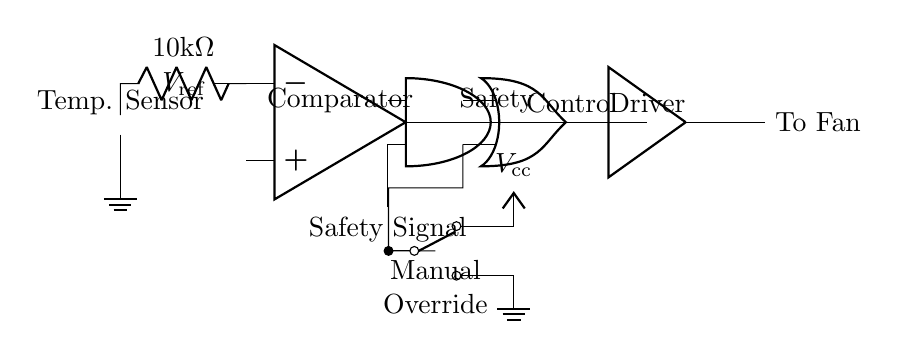What type of sensor is used in this circuit? The circuit contains a thermistor, which is a type of temperature sensor. This is indicated by the labeled component in the diagram.
Answer: Thermistor What is the reference voltage labeled in the circuit? The reference voltage is denoted as V_ref near the input of the comparator. This can be seen as a connection pointing towards the negative terminal of the operational amplifier.
Answer: V_ref What outputs from the safety input and comparator are needed for the cooling fan to operate? For the cooling fan to operate, both outputs from the safety signal and the comparator must be high, indicating that the AND gate will need both inputs to allow current through to the next stage.
Answer: High What component provides manual override control? The circuit includes a single pole double throw switch for manual override, which connects directly to the OR gate. This is positioned clearly in the lower part of the circuit, making it easily identifiable.
Answer: SPDT switch How many logic levels are present in this circuit to control the fan? There are three significant logic influences in the circuit: the comparator output, the safety signal input into the AND gate, and the manual override via the OR gate. This creates a tiered decision framework for fan operation.
Answer: Three What is the function of the buffer in this circuit? The buffer serves to isolate the fan control signal and ensures that the fan receives a strong enough signal to operate based on the control logic provided by the previous gates. This can be inferred from the placement of the buffer connecting the OR gate output to the fan.
Answer: Signal isolation What type of logic gate is used to combine the comparator output and the safety signal? The circuit uses an AND gate to combine these two signals. This is deduced from the diagram where the outputs from the comparator and safety signal converge at the AND gate before proceeding forward in the circuit.
Answer: AND gate 